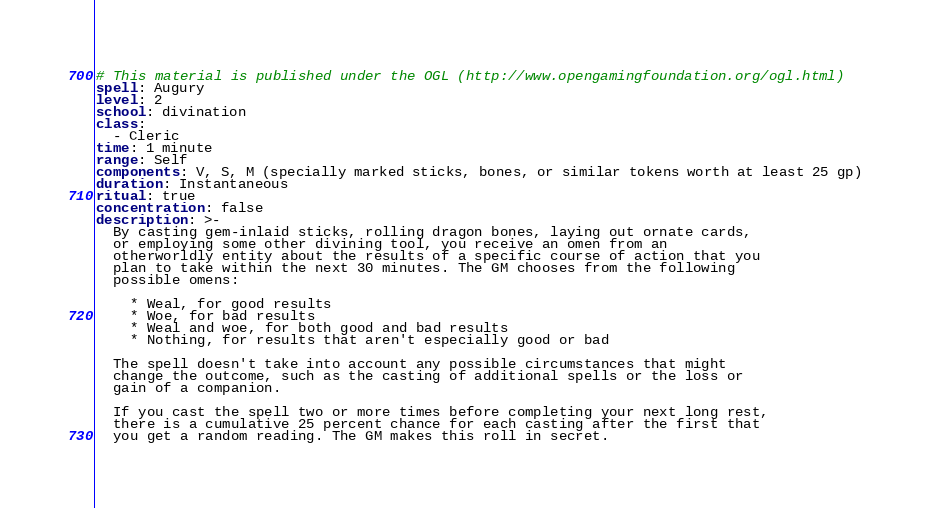<code> <loc_0><loc_0><loc_500><loc_500><_YAML_># This material is published under the OGL (http://www.opengamingfoundation.org/ogl.html)
spell: Augury
level: 2
school: divination
class:
  - Cleric
time: 1 minute
range: Self
components: V, S, M (specially marked sticks, bones, or similar tokens worth at least 25 gp)
duration: Instantaneous
ritual: true
concentration: false
description: >-
  By casting gem-inlaid sticks, rolling dragon bones, laying out ornate cards,
  or employing some other divining tool, you receive an omen from an
  otherworldly entity about the results of a specific course of action that you
  plan to take within the next 30 minutes. The GM chooses from the following
  possible omens:

    * Weal, for good results
    * Woe, for bad results
    * Weal and woe, for both good and bad results
    * Nothing, for results that aren't especially good or bad

  The spell doesn't take into account any possible circumstances that might
  change the outcome, such as the casting of additional spells or the loss or
  gain of a companion.

  If you cast the spell two or more times before completing your next long rest,
  there is a cumulative 25 percent chance for each casting after the first that
  you get a random reading. The GM makes this roll in secret.
</code> 